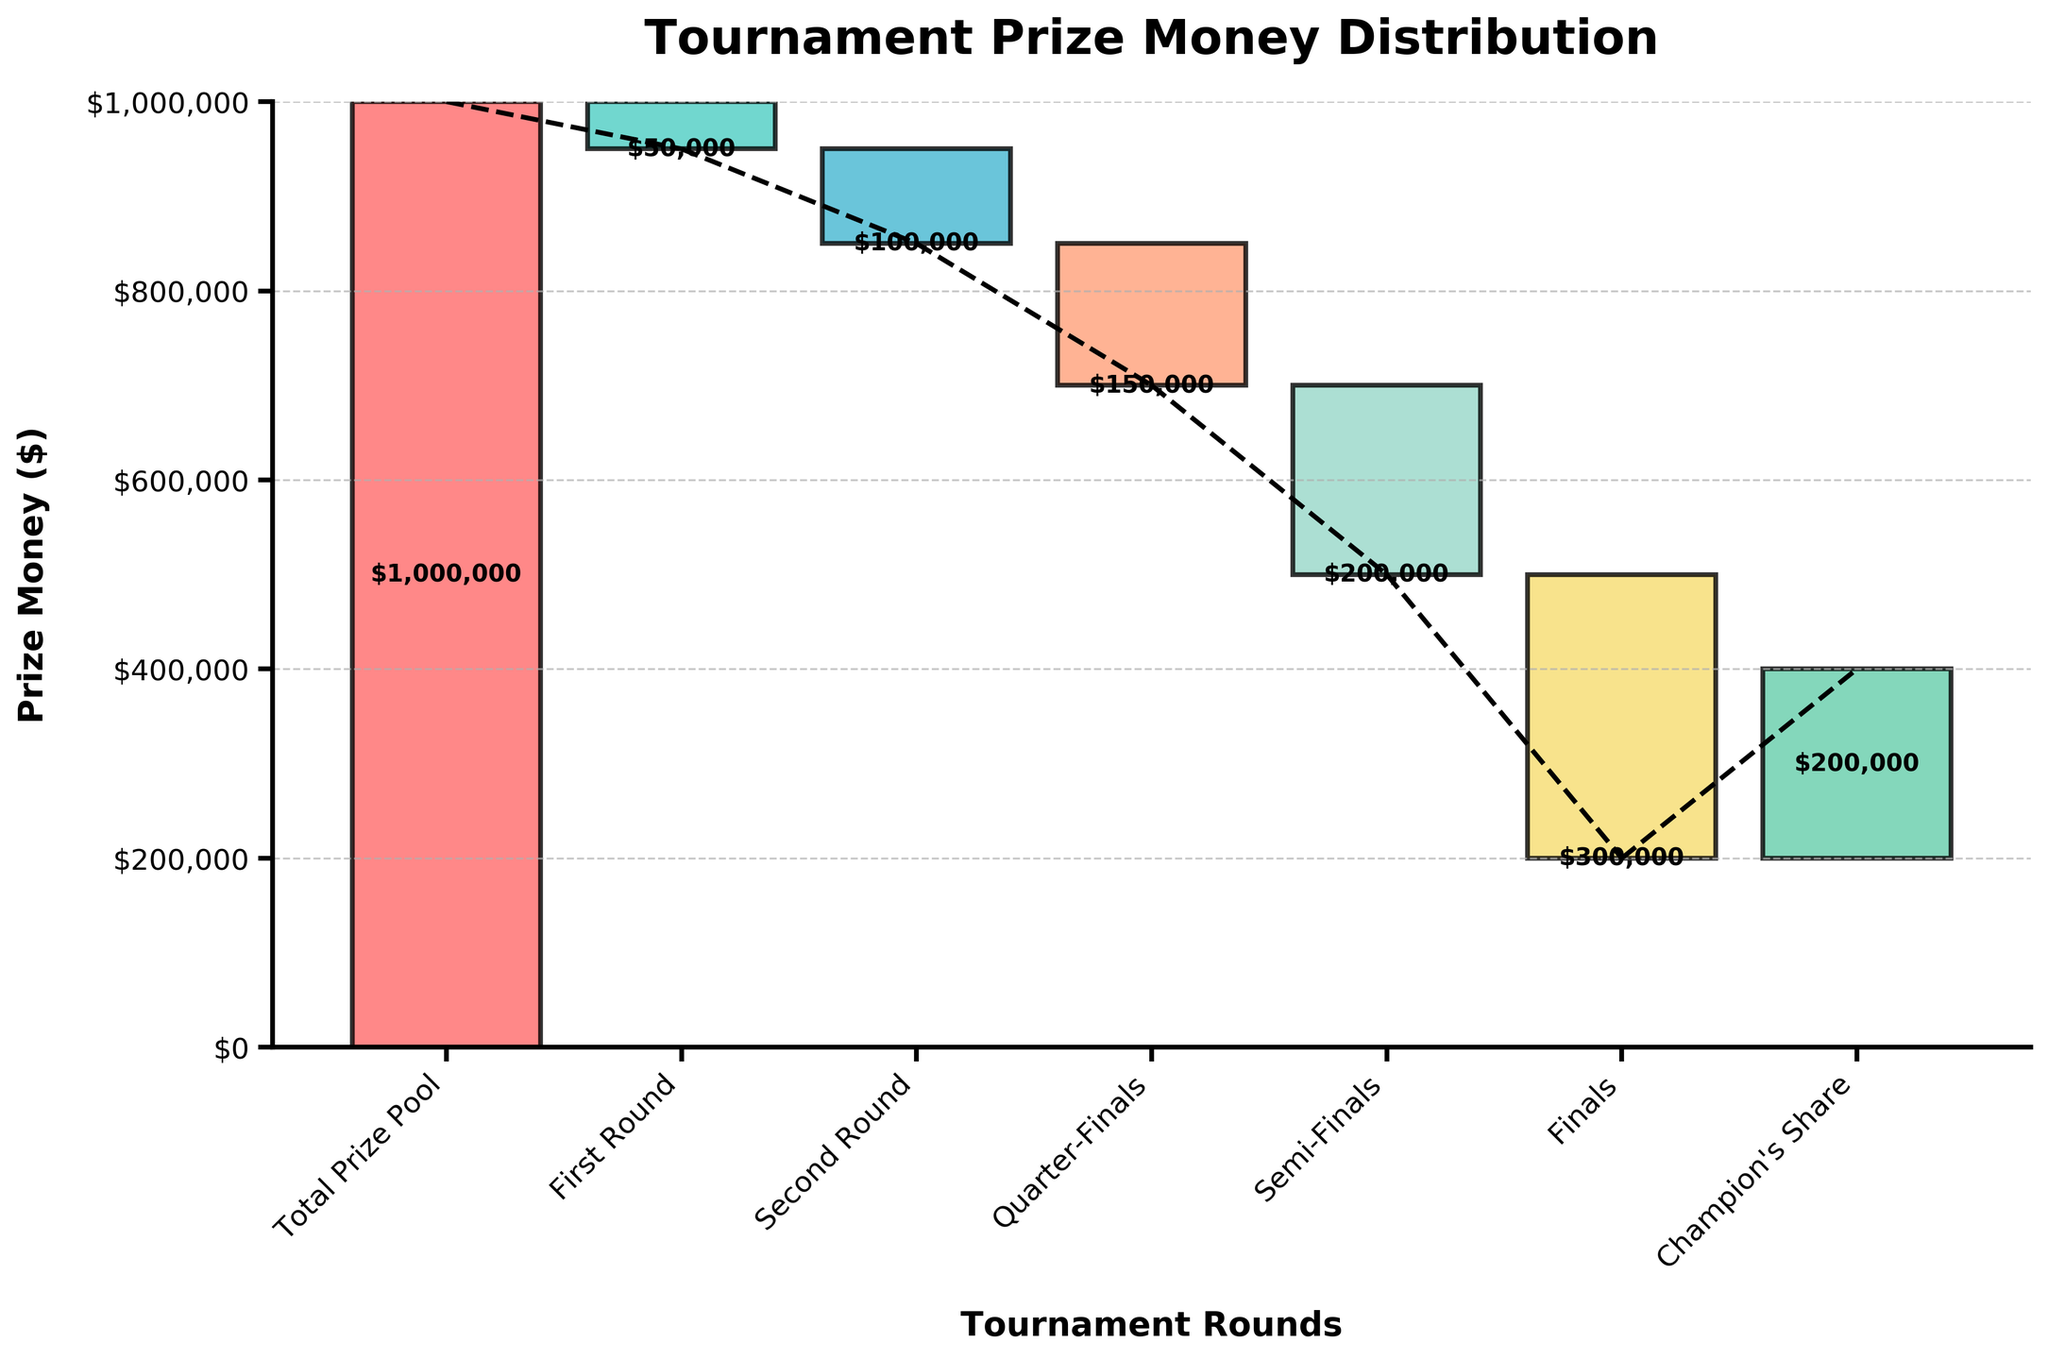What is the title of the chart? The title of the chart is displayed at the top of the figure. It typically describes the main subject of the chart.
Answer: Tournament Prize Money Distribution How much prize money is distributed in the First Round? The prize money for each round is labeled on the corresponding bar in the chart. The First Round shows a prize money of -$50,000.
Answer: $50,000 Does the Champion's Share contribute positively or negatively to the total prize pool? The bar for the Champion's Share is positioned above the preceding bar, indicating a positive contribution.
Answer: Positively What is the total prize pool amount? The total prize pool is given in the first bar. The cumulative prize money across all rounds starts with the total prize pool of $1,000,000.
Answer: $1,000,000 How does the prize money change from the Semi-Finals to the Finals? The prize money is deducted further in the Finals compared to the Semi-Finals. The chart shows a change from -$200,000 in the Semi-Finals to -$300,000 in the Finals.
Answer: $100,000 decrease What is the cumulative prize money after the Semi-Finals? The cumulative prize money at each stage can be found by summing the values up to that stage. After the Semi-Finals, the cumulative prize money is: $1,000,000 - $50,000 - $100,000 - $150,000 - $200,000 = $500,000.
Answer: $500,000 What round sees the highest amount of prize money deducted? By comparing the bars' lengths, the Finals show the highest deduction of prize money, totaling -$300,000.
Answer: Finals What is the prize money awarded to the champion? The Champion's Share is explicitly labeled on the last bar of the chart. It shows a positive amount of $200,000.
Answer: $200,000 Which color represents the Semi-Finals? Observing the color coding, the Semi-Finals are represented by a distinct color within the chart. This color is fourth in the sequence from the left.
Answer: A shade of orange (peachy color) How does the cumulative prize money change from the First Round to the Second Round? The cumulative prize money after the First Round is $950,000 and after the Second Round is $850,000. Thus, the change in cumulative prize money is $950,000 - $850,000 = $100,000.
Answer: $100,000 decrease 